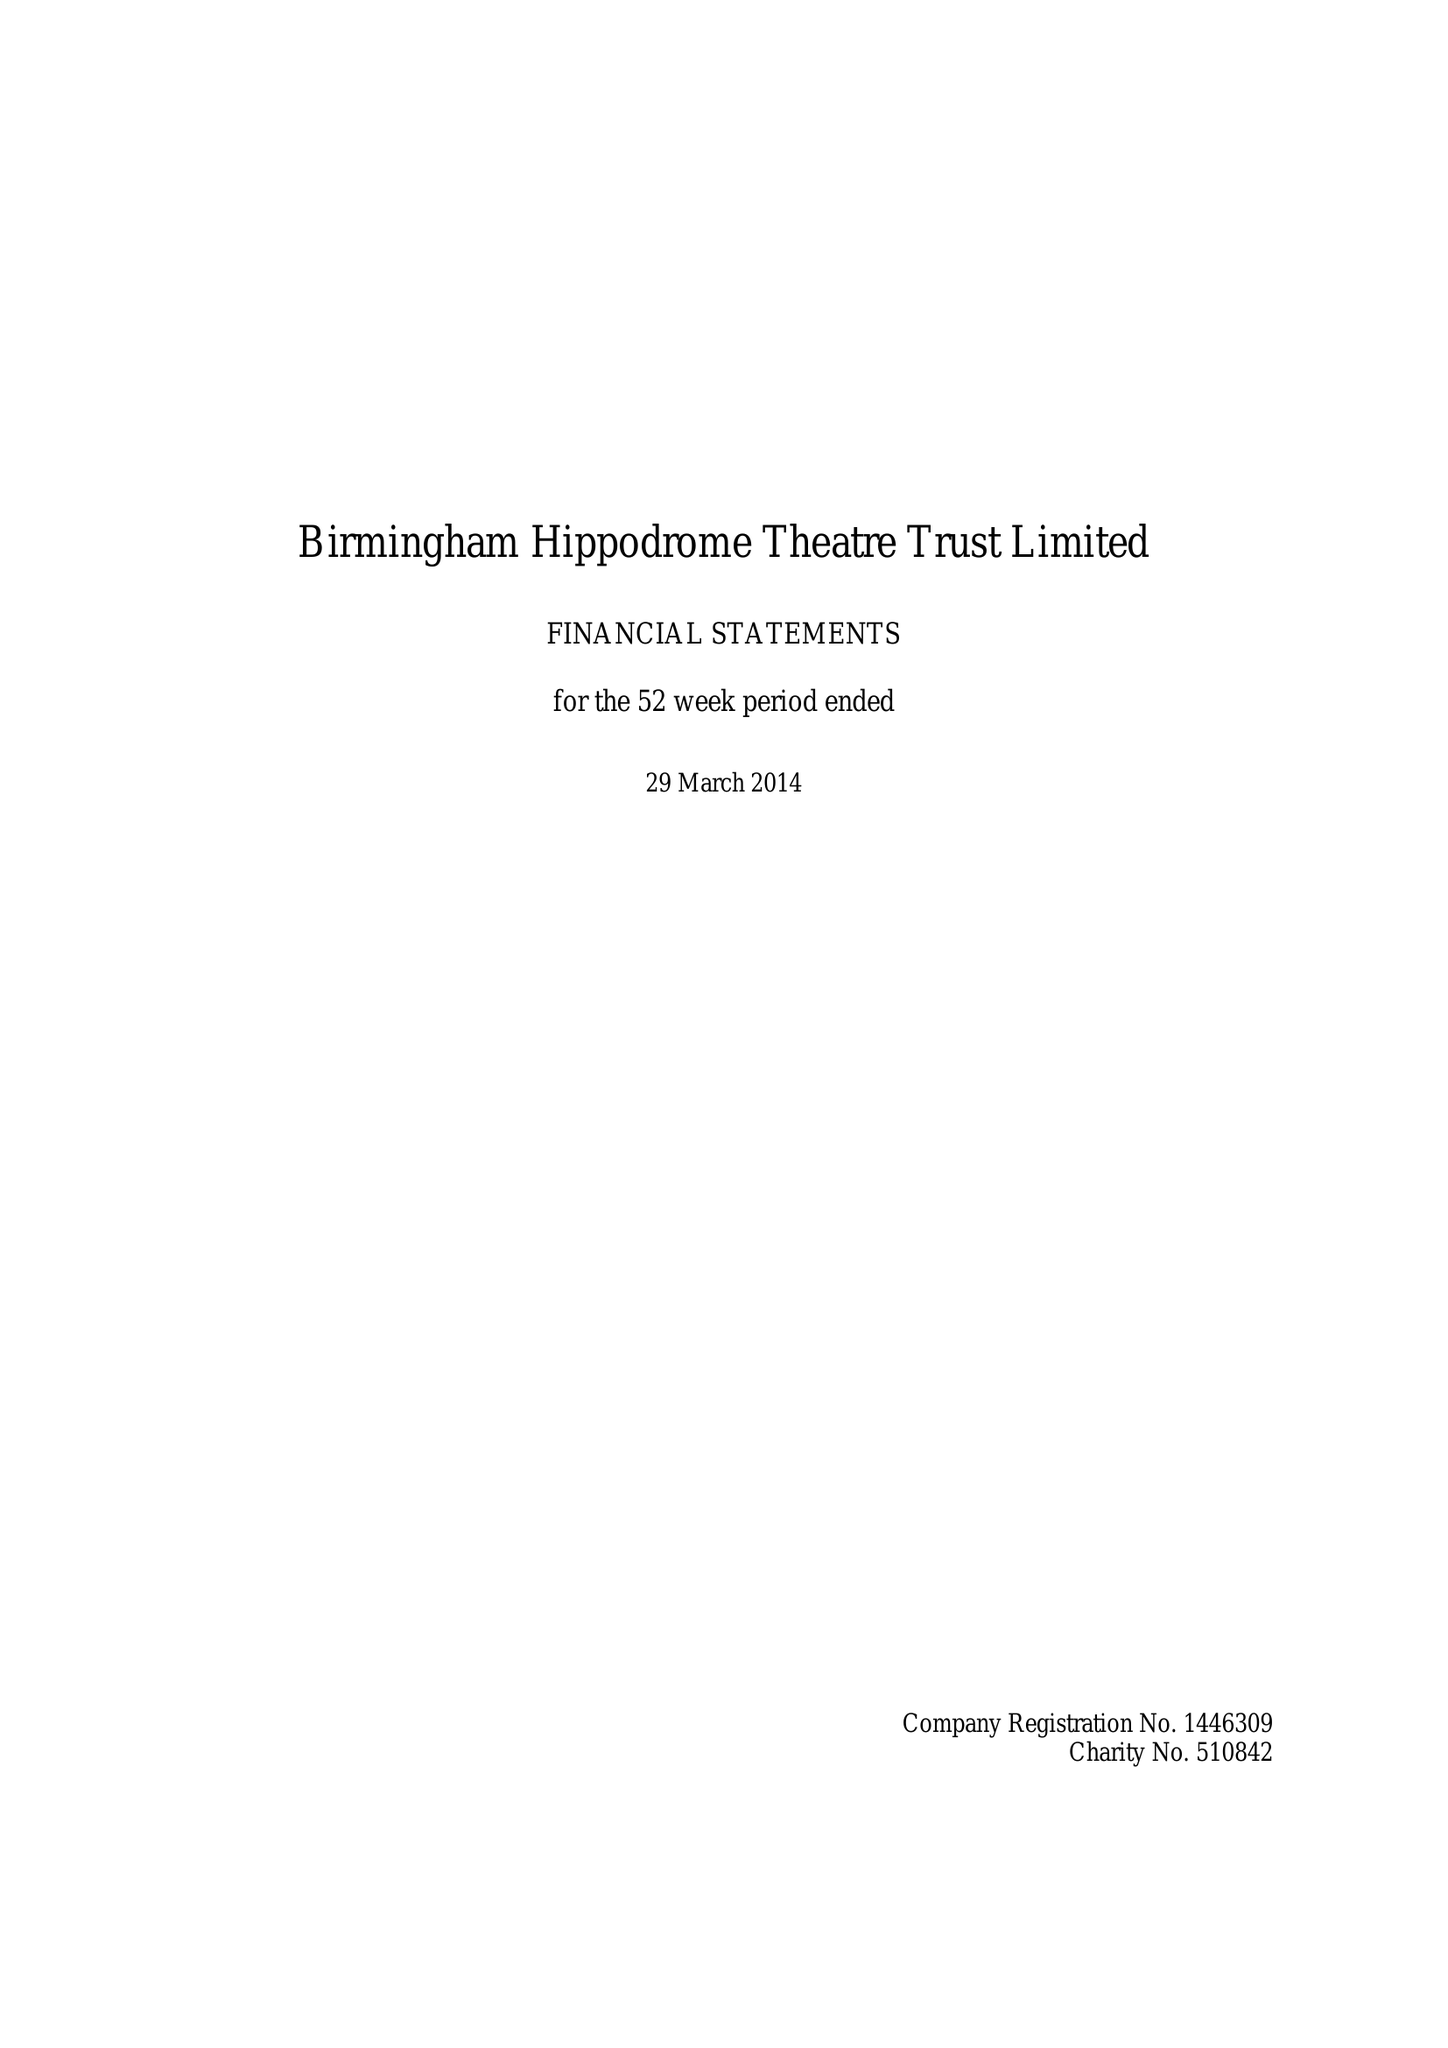What is the value for the charity_number?
Answer the question using a single word or phrase. 510842 